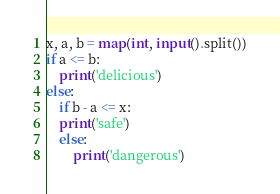Convert code to text. <code><loc_0><loc_0><loc_500><loc_500><_Python_>x, a, b = map(int, input().split())
if a <= b:
    print('delicious')
else:
    if b - a <= x:
    print('safe')
    else:
        print('dangerous')</code> 